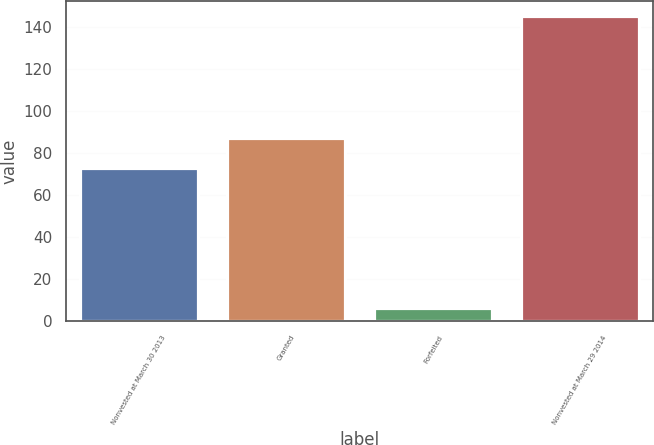<chart> <loc_0><loc_0><loc_500><loc_500><bar_chart><fcel>Nonvested at March 30 2013<fcel>Granted<fcel>Forfeited<fcel>Nonvested at March 29 2014<nl><fcel>73<fcel>86.9<fcel>6<fcel>145<nl></chart> 